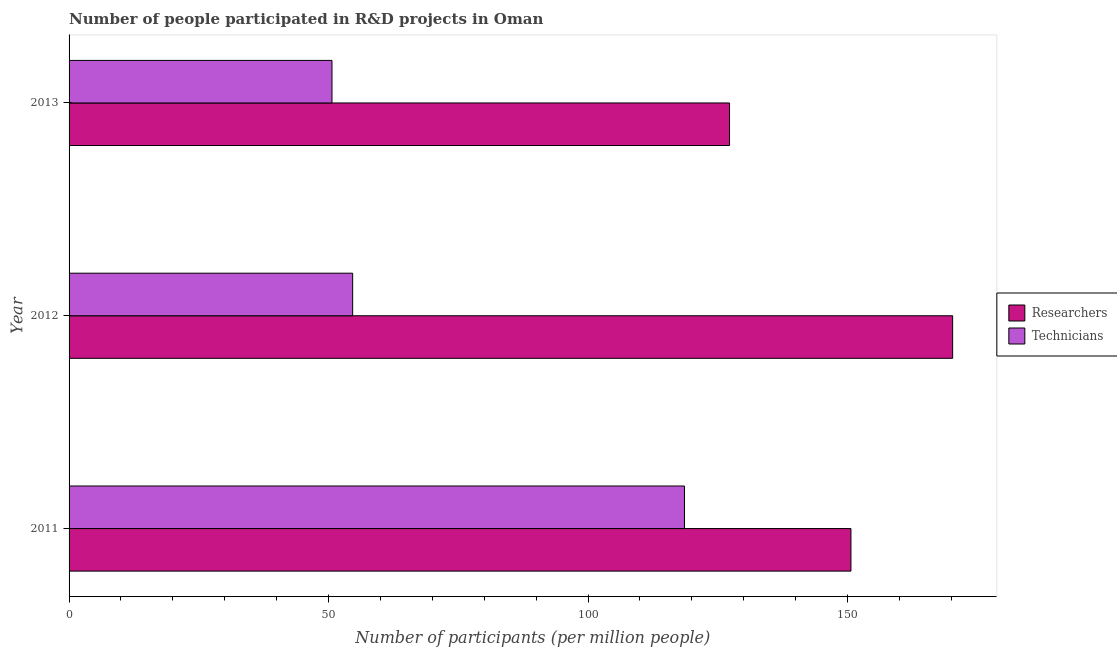How many groups of bars are there?
Ensure brevity in your answer.  3. Are the number of bars per tick equal to the number of legend labels?
Give a very brief answer. Yes. Are the number of bars on each tick of the Y-axis equal?
Your answer should be very brief. Yes. How many bars are there on the 1st tick from the top?
Provide a short and direct response. 2. What is the label of the 1st group of bars from the top?
Offer a very short reply. 2013. In how many cases, is the number of bars for a given year not equal to the number of legend labels?
Make the answer very short. 0. What is the number of researchers in 2011?
Offer a terse response. 150.66. Across all years, what is the maximum number of technicians?
Offer a terse response. 118.59. Across all years, what is the minimum number of technicians?
Your response must be concise. 50.66. In which year was the number of technicians maximum?
Ensure brevity in your answer.  2011. In which year was the number of technicians minimum?
Provide a succinct answer. 2013. What is the total number of technicians in the graph?
Ensure brevity in your answer.  223.9. What is the difference between the number of researchers in 2012 and that in 2013?
Ensure brevity in your answer.  42.99. What is the difference between the number of technicians in 2013 and the number of researchers in 2011?
Offer a very short reply. -100. What is the average number of technicians per year?
Make the answer very short. 74.63. In the year 2013, what is the difference between the number of technicians and number of researchers?
Offer a terse response. -76.61. What is the ratio of the number of technicians in 2012 to that in 2013?
Offer a very short reply. 1.08. Is the number of technicians in 2012 less than that in 2013?
Provide a short and direct response. No. Is the difference between the number of researchers in 2011 and 2013 greater than the difference between the number of technicians in 2011 and 2013?
Your response must be concise. No. What is the difference between the highest and the second highest number of researchers?
Provide a short and direct response. 19.6. What is the difference between the highest and the lowest number of technicians?
Your answer should be very brief. 67.92. Is the sum of the number of researchers in 2011 and 2013 greater than the maximum number of technicians across all years?
Offer a terse response. Yes. What does the 1st bar from the top in 2013 represents?
Provide a succinct answer. Technicians. What does the 2nd bar from the bottom in 2011 represents?
Your answer should be very brief. Technicians. Are all the bars in the graph horizontal?
Your answer should be compact. Yes. What is the difference between two consecutive major ticks on the X-axis?
Your response must be concise. 50. Are the values on the major ticks of X-axis written in scientific E-notation?
Offer a terse response. No. Does the graph contain grids?
Provide a short and direct response. No. What is the title of the graph?
Ensure brevity in your answer.  Number of people participated in R&D projects in Oman. What is the label or title of the X-axis?
Your answer should be very brief. Number of participants (per million people). What is the Number of participants (per million people) in Researchers in 2011?
Keep it short and to the point. 150.66. What is the Number of participants (per million people) of Technicians in 2011?
Your response must be concise. 118.59. What is the Number of participants (per million people) of Researchers in 2012?
Offer a terse response. 170.26. What is the Number of participants (per million people) in Technicians in 2012?
Provide a short and direct response. 54.65. What is the Number of participants (per million people) of Researchers in 2013?
Offer a very short reply. 127.27. What is the Number of participants (per million people) in Technicians in 2013?
Keep it short and to the point. 50.66. Across all years, what is the maximum Number of participants (per million people) of Researchers?
Make the answer very short. 170.26. Across all years, what is the maximum Number of participants (per million people) in Technicians?
Your answer should be very brief. 118.59. Across all years, what is the minimum Number of participants (per million people) in Researchers?
Your response must be concise. 127.27. Across all years, what is the minimum Number of participants (per million people) of Technicians?
Give a very brief answer. 50.66. What is the total Number of participants (per million people) in Researchers in the graph?
Give a very brief answer. 448.2. What is the total Number of participants (per million people) of Technicians in the graph?
Your answer should be very brief. 223.9. What is the difference between the Number of participants (per million people) in Researchers in 2011 and that in 2012?
Give a very brief answer. -19.6. What is the difference between the Number of participants (per million people) of Technicians in 2011 and that in 2012?
Your response must be concise. 63.94. What is the difference between the Number of participants (per million people) in Researchers in 2011 and that in 2013?
Keep it short and to the point. 23.39. What is the difference between the Number of participants (per million people) in Technicians in 2011 and that in 2013?
Your answer should be compact. 67.92. What is the difference between the Number of participants (per million people) in Researchers in 2012 and that in 2013?
Your answer should be compact. 42.99. What is the difference between the Number of participants (per million people) in Technicians in 2012 and that in 2013?
Your answer should be compact. 3.98. What is the difference between the Number of participants (per million people) of Researchers in 2011 and the Number of participants (per million people) of Technicians in 2012?
Ensure brevity in your answer.  96.02. What is the difference between the Number of participants (per million people) of Researchers in 2011 and the Number of participants (per million people) of Technicians in 2013?
Keep it short and to the point. 100. What is the difference between the Number of participants (per million people) of Researchers in 2012 and the Number of participants (per million people) of Technicians in 2013?
Make the answer very short. 119.6. What is the average Number of participants (per million people) in Researchers per year?
Provide a short and direct response. 149.4. What is the average Number of participants (per million people) in Technicians per year?
Ensure brevity in your answer.  74.63. In the year 2011, what is the difference between the Number of participants (per million people) of Researchers and Number of participants (per million people) of Technicians?
Offer a terse response. 32.08. In the year 2012, what is the difference between the Number of participants (per million people) in Researchers and Number of participants (per million people) in Technicians?
Your answer should be compact. 115.62. In the year 2013, what is the difference between the Number of participants (per million people) in Researchers and Number of participants (per million people) in Technicians?
Provide a short and direct response. 76.61. What is the ratio of the Number of participants (per million people) of Researchers in 2011 to that in 2012?
Provide a short and direct response. 0.88. What is the ratio of the Number of participants (per million people) in Technicians in 2011 to that in 2012?
Make the answer very short. 2.17. What is the ratio of the Number of participants (per million people) of Researchers in 2011 to that in 2013?
Provide a short and direct response. 1.18. What is the ratio of the Number of participants (per million people) in Technicians in 2011 to that in 2013?
Your answer should be compact. 2.34. What is the ratio of the Number of participants (per million people) in Researchers in 2012 to that in 2013?
Keep it short and to the point. 1.34. What is the ratio of the Number of participants (per million people) of Technicians in 2012 to that in 2013?
Your answer should be very brief. 1.08. What is the difference between the highest and the second highest Number of participants (per million people) of Researchers?
Your answer should be very brief. 19.6. What is the difference between the highest and the second highest Number of participants (per million people) of Technicians?
Give a very brief answer. 63.94. What is the difference between the highest and the lowest Number of participants (per million people) in Researchers?
Keep it short and to the point. 42.99. What is the difference between the highest and the lowest Number of participants (per million people) of Technicians?
Offer a very short reply. 67.92. 